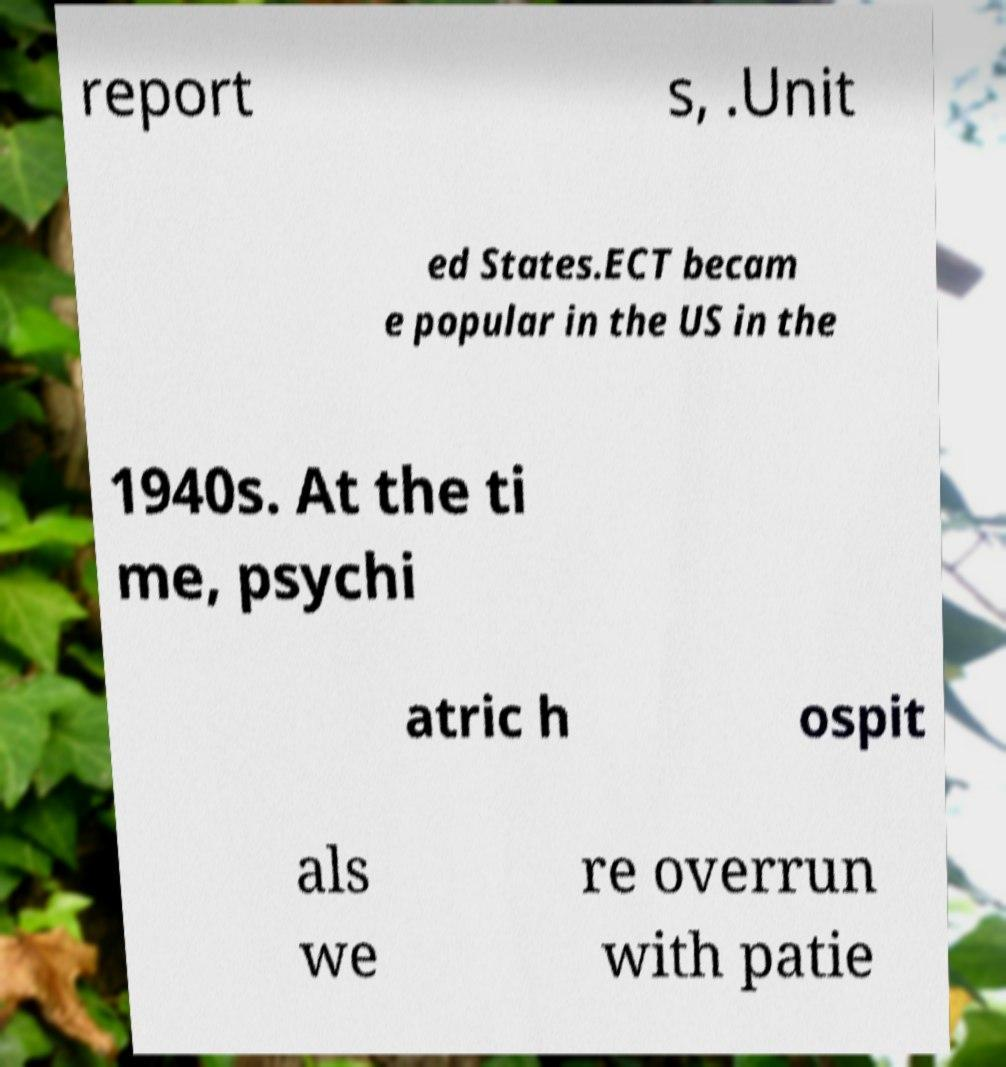Can you accurately transcribe the text from the provided image for me? report s, .Unit ed States.ECT becam e popular in the US in the 1940s. At the ti me, psychi atric h ospit als we re overrun with patie 